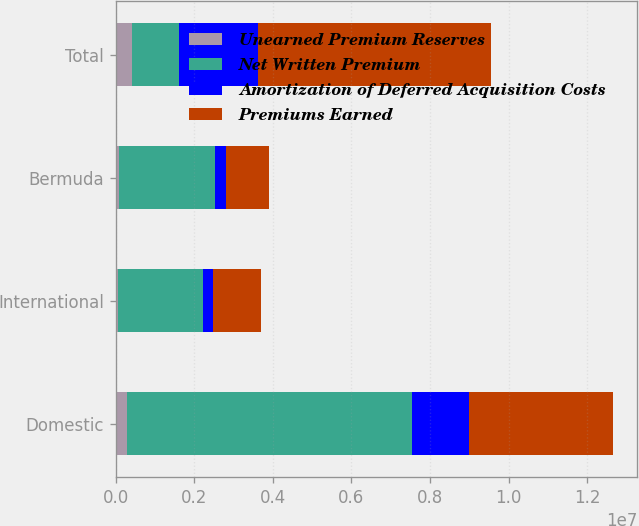Convert chart. <chart><loc_0><loc_0><loc_500><loc_500><stacked_bar_chart><ecel><fcel>Domestic<fcel>International<fcel>Bermuda<fcel>Total<nl><fcel>Unearned Premium Reserves<fcel>289636<fcel>53186<fcel>68765<fcel>411587<nl><fcel>Net Written Premium<fcel>7.25404e+06<fcel>2.1755e+06<fcel>2.45478e+06<fcel>1.20204e+06<nl><fcel>Amortization of Deferred Acquisition Costs<fcel>1.46029e+06<fcel>253626<fcel>286639<fcel>2.00056e+06<nl><fcel>Premiums Earned<fcel>3.64255e+06<fcel>1.20204e+06<fcel>1.09325e+06<fcel>5.93784e+06<nl></chart> 